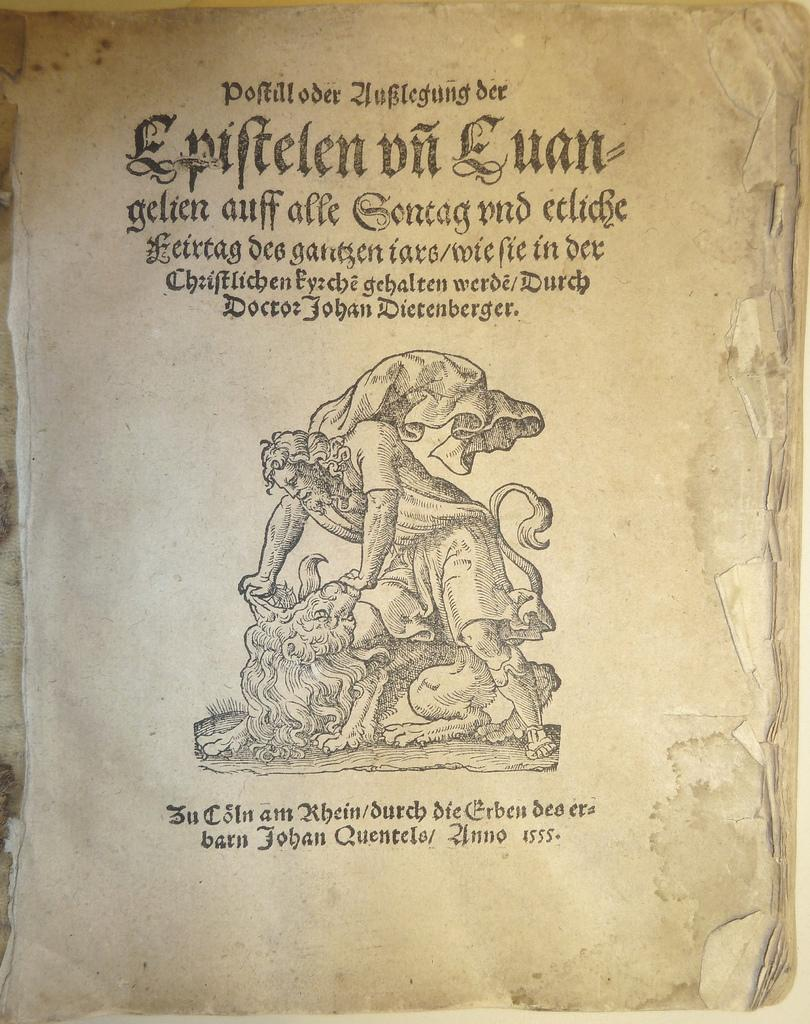What is the medium of the image? The image is on a paper. What type of subject is depicted in the image? There is a picture of a person and a picture of an animal on the paper. Are there any words or text in the image? Yes, there are letters on the paper. What type of fruit is being sold in the image? There is no fruit or any indication of a sale in the image; it features a picture of a person and an animal with letters on a paper. What season is depicted in the image? The image does not depict a specific season, as it only features a person, an animal, and letters on a paper. 